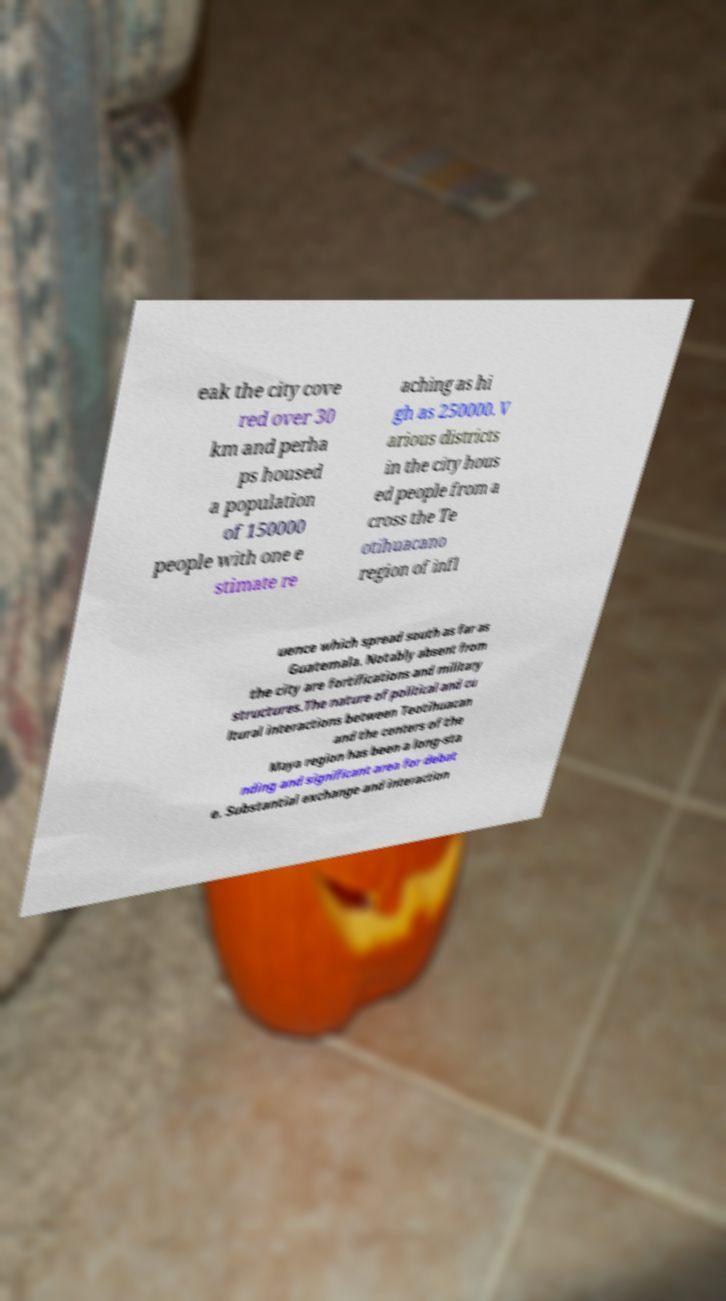Could you assist in decoding the text presented in this image and type it out clearly? eak the city cove red over 30 km and perha ps housed a population of 150000 people with one e stimate re aching as hi gh as 250000. V arious districts in the city hous ed people from a cross the Te otihuacano region of infl uence which spread south as far as Guatemala. Notably absent from the city are fortifications and military structures.The nature of political and cu ltural interactions between Teotihuacan and the centers of the Maya region has been a long-sta nding and significant area for debat e. Substantial exchange and interaction 